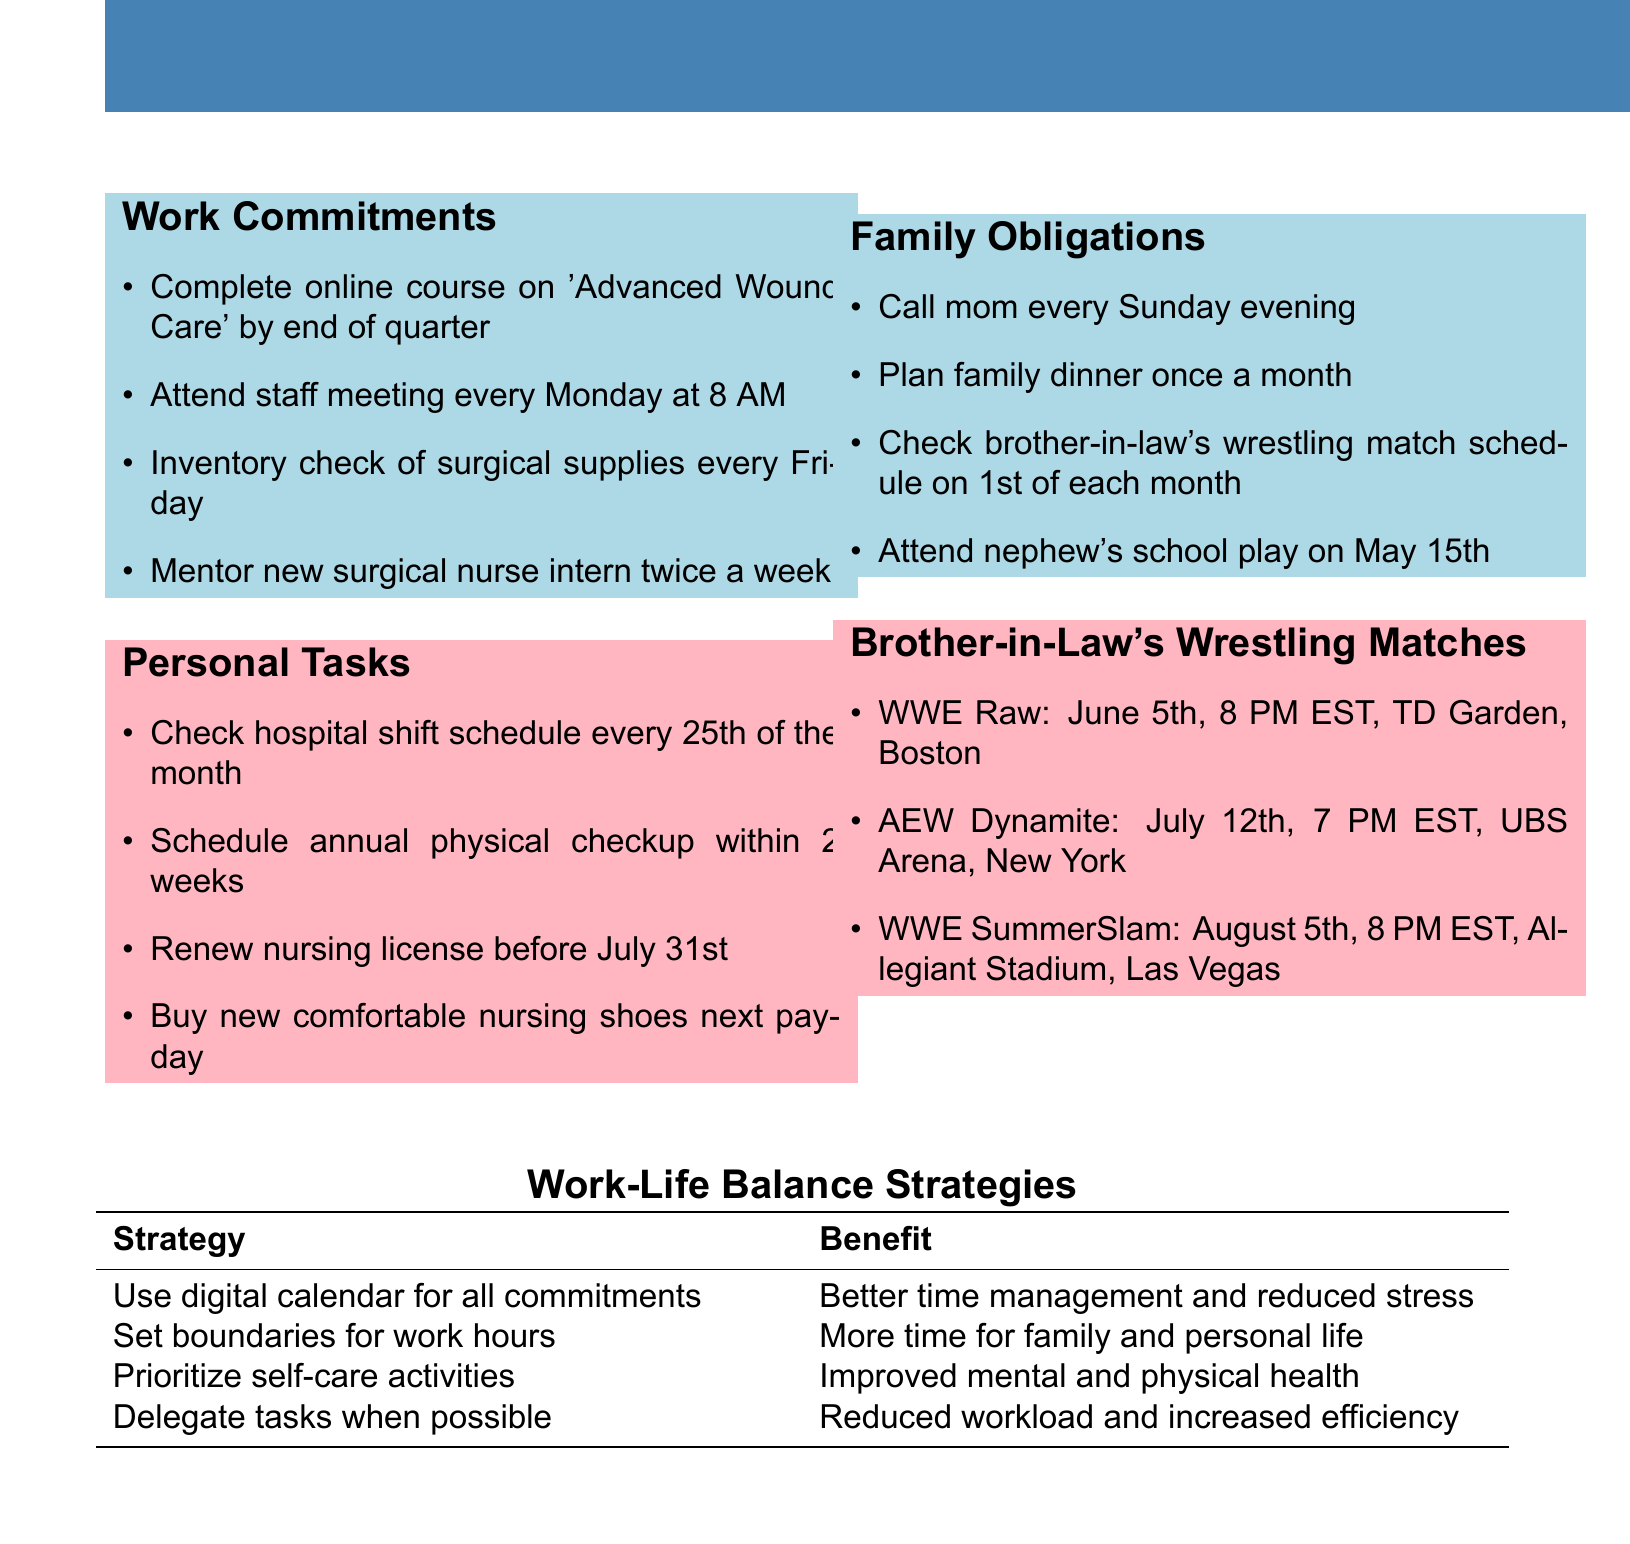What is the deadline to renew the nursing license? The nursing license must be renewed before July 31st, as stated in the personal tasks section.
Answer: Before July 31st How often is the staff meeting scheduled? The staff meeting occurs every Monday at 8 AM, as mentioned in the work commitments section.
Answer: Every Monday at 8 AM When is the nephew's school play? The date of the nephew's school play is specified as May 15th in the family obligations section.
Answer: May 15th What is the first family obligation task of the month? The first family obligation task is to check the brother-in-law's wrestling match schedule, which occurs on the 1st of each month.
Answer: Check brother-in-law's wrestling match schedule What event is happening on June 5th? WWE Raw is scheduled to occur on June 5th at 8 PM EST, as listed in the brother-in-law's wrestling matches section.
Answer: WWE Raw What is one strategy for work-life balance mentioned? The document provides various strategies, including using a digital calendar for all commitments to manage time better.
Answer: Use digital calendar for all commitments How many personal tasks are listed? There are four personal tasks outlined in the personal tasks section of the document.
Answer: Four Which task is to be completed every Friday? An inventory check of surgical supplies is to be completed every Friday, as per the work commitments section.
Answer: Inventory check of surgical supplies What benefit is associated with setting boundaries for work hours? One listed benefit of setting boundaries for work hours is having more time for family and personal life.
Answer: More time for family and personal life 